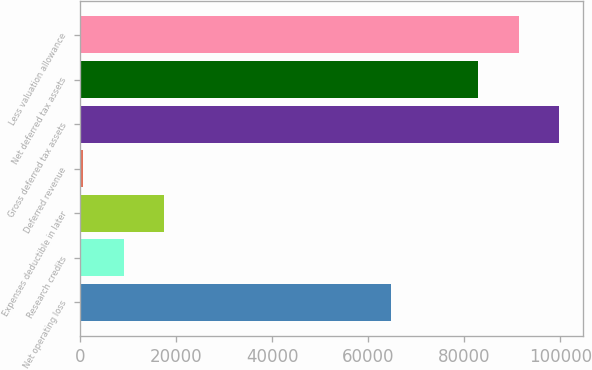Convert chart. <chart><loc_0><loc_0><loc_500><loc_500><bar_chart><fcel>Net operating loss<fcel>Research credits<fcel>Expenses deductible in later<fcel>Deferred revenue<fcel>Gross deferred tax assets<fcel>Net deferred tax assets<fcel>Less valuation allowance<nl><fcel>64705<fcel>9006.1<fcel>17407.2<fcel>605<fcel>99702.2<fcel>82900<fcel>91301.1<nl></chart> 